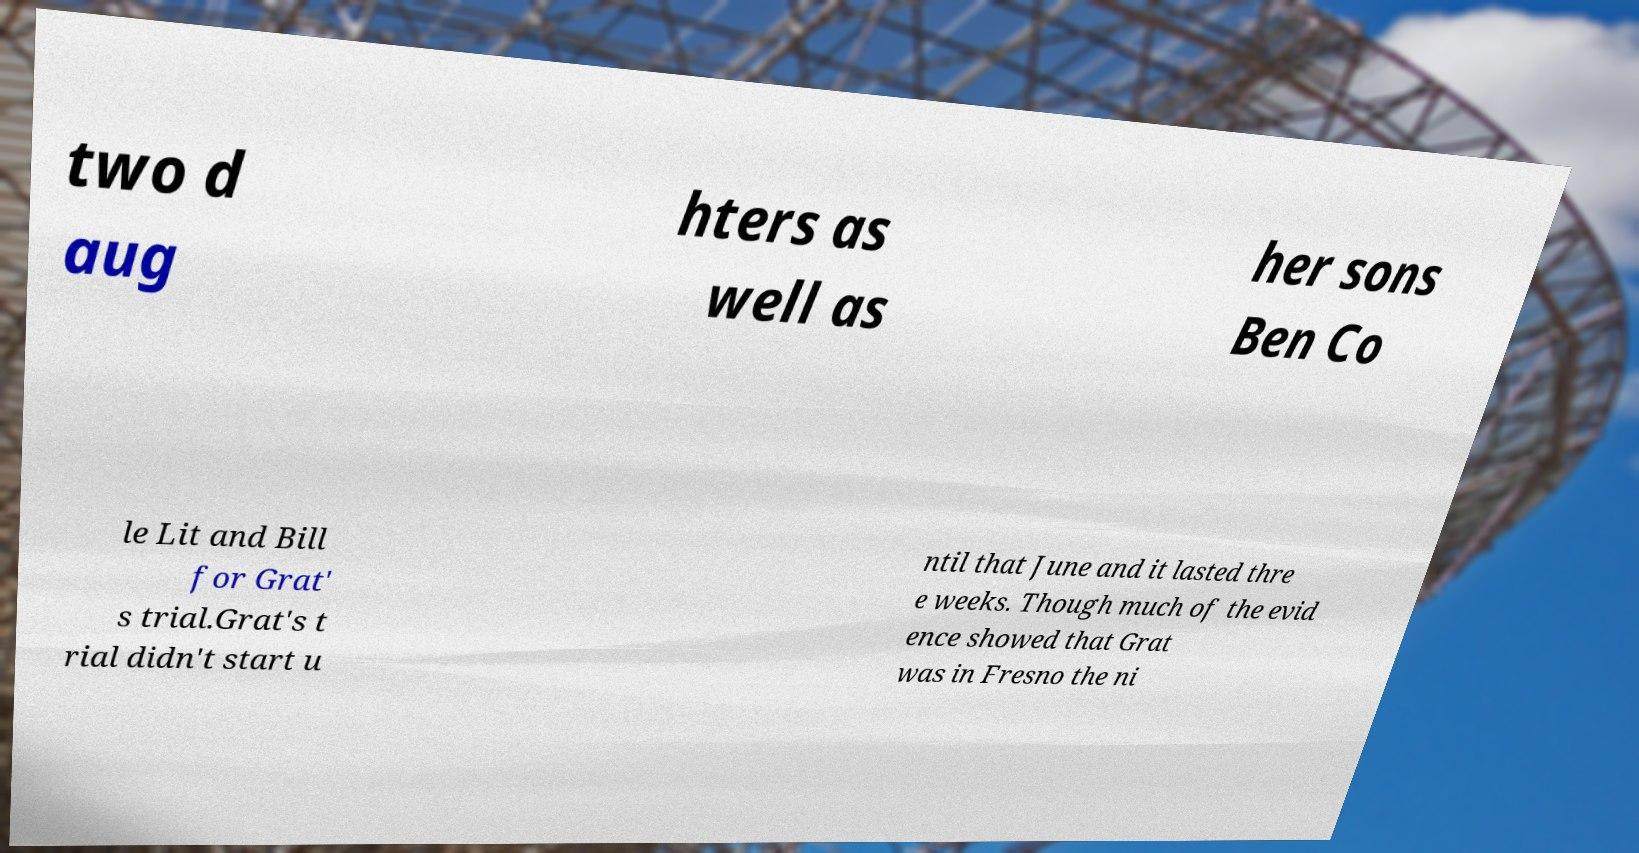There's text embedded in this image that I need extracted. Can you transcribe it verbatim? two d aug hters as well as her sons Ben Co le Lit and Bill for Grat' s trial.Grat's t rial didn't start u ntil that June and it lasted thre e weeks. Though much of the evid ence showed that Grat was in Fresno the ni 